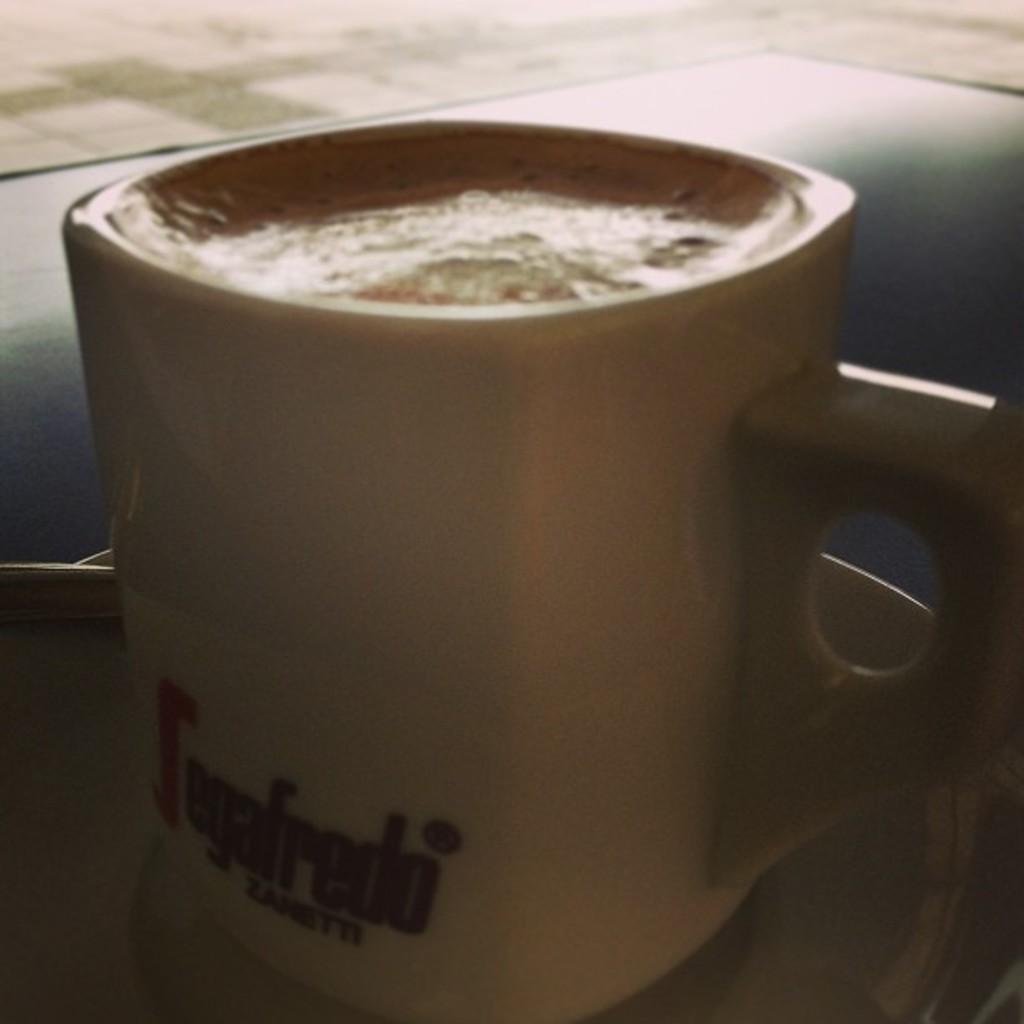Describe this image in one or two sentences. Here we can see cup with coffee on surface. 